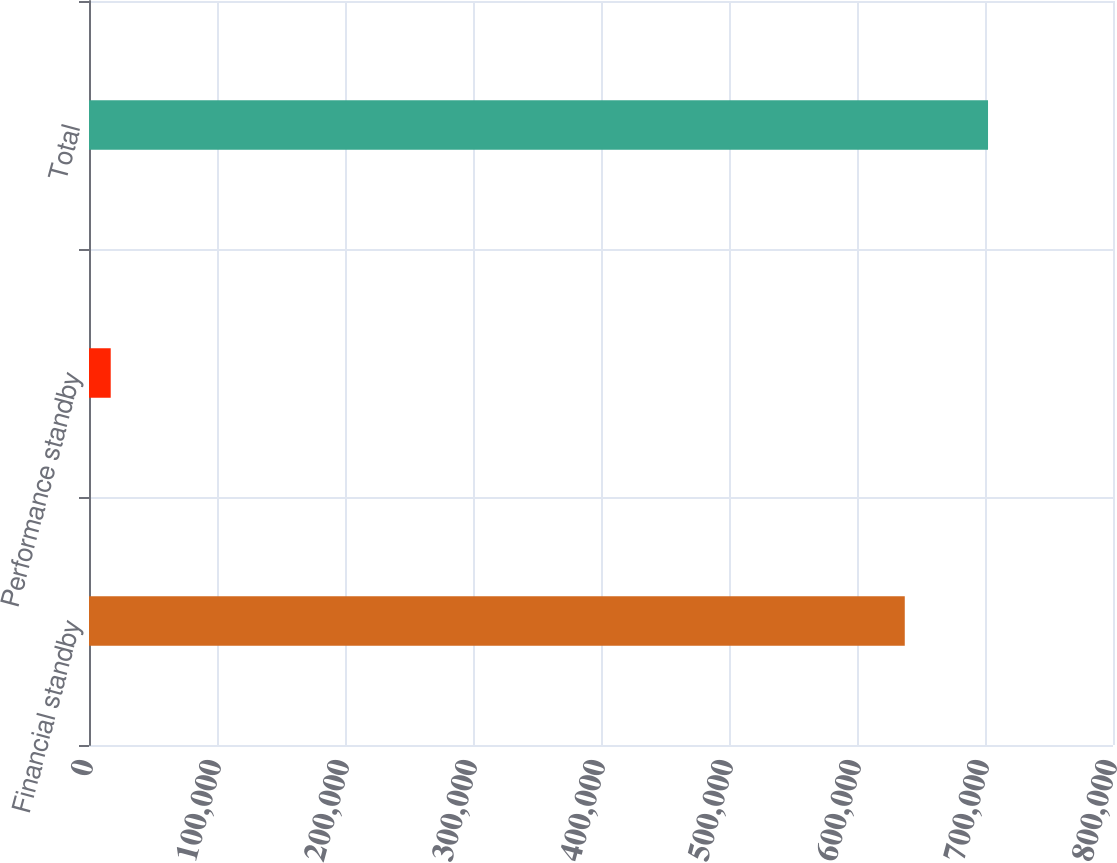Convert chart to OTSL. <chart><loc_0><loc_0><loc_500><loc_500><bar_chart><fcel>Financial standby<fcel>Performance standby<fcel>Total<nl><fcel>637321<fcel>16970<fcel>702368<nl></chart> 